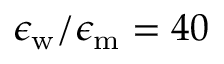Convert formula to latex. <formula><loc_0><loc_0><loc_500><loc_500>\epsilon _ { w } / \epsilon _ { m } = 4 0</formula> 